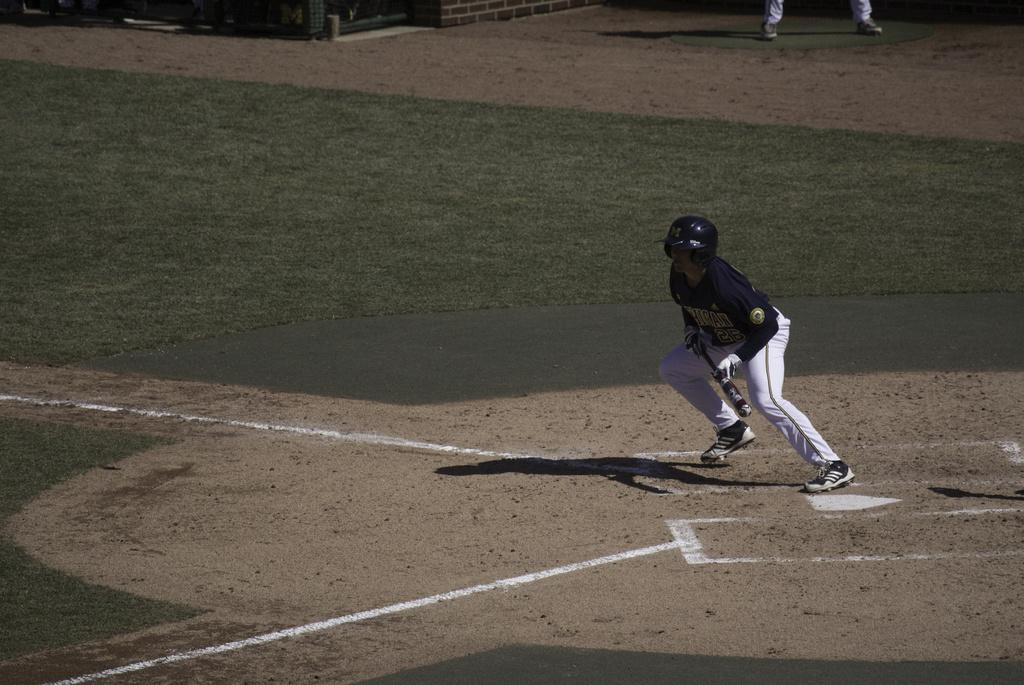What is the person in the image wearing on their head? The person in the image is wearing a helmet. What is the person holding in their hand? The person is holding a bat. What can be seen in the background of the image? There is a ground carpet and objects visible in the background. Can you describe any other people in the image? There are legs of a person visible in the background. What type of veil is the person wearing over their face in the image? There is no veil present in the image; the person is wearing a helmet. Can you tell me how many kettles are visible in the image? There are no kettles visible in the image. 